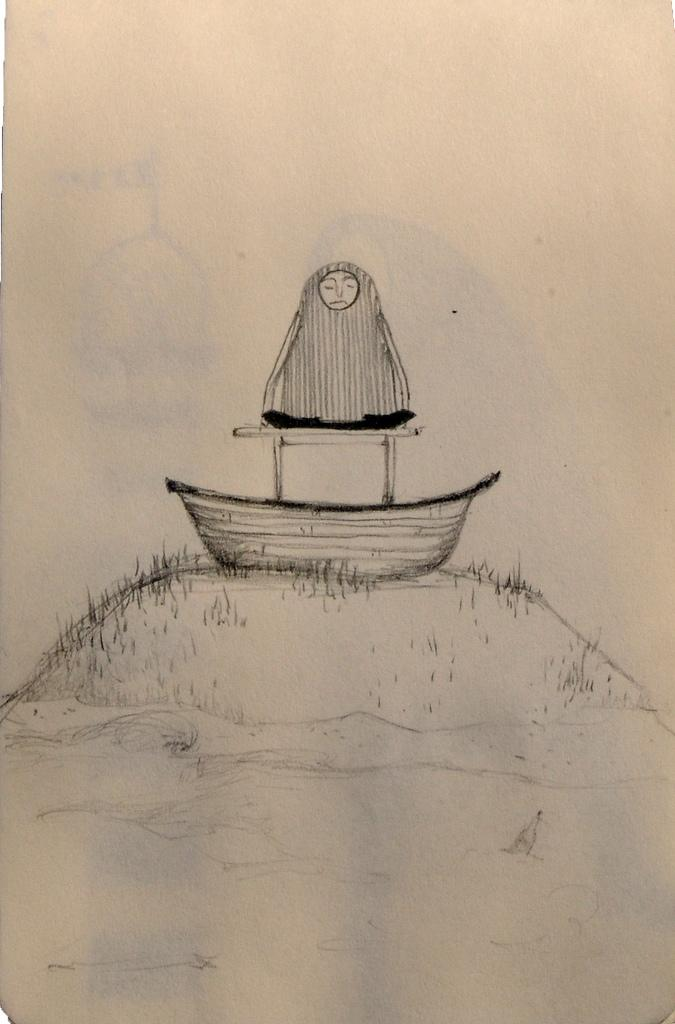What is depicted in the drawing in the image? There is a drawing of a boat and a person in the image. What color is the background of the image? The background of the image is cream-colored. What type of shirt is the person wearing in the image? There is no person wearing a shirt in the image, as the person depicted is a drawing. 